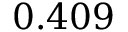<formula> <loc_0><loc_0><loc_500><loc_500>0 . 4 0 9</formula> 